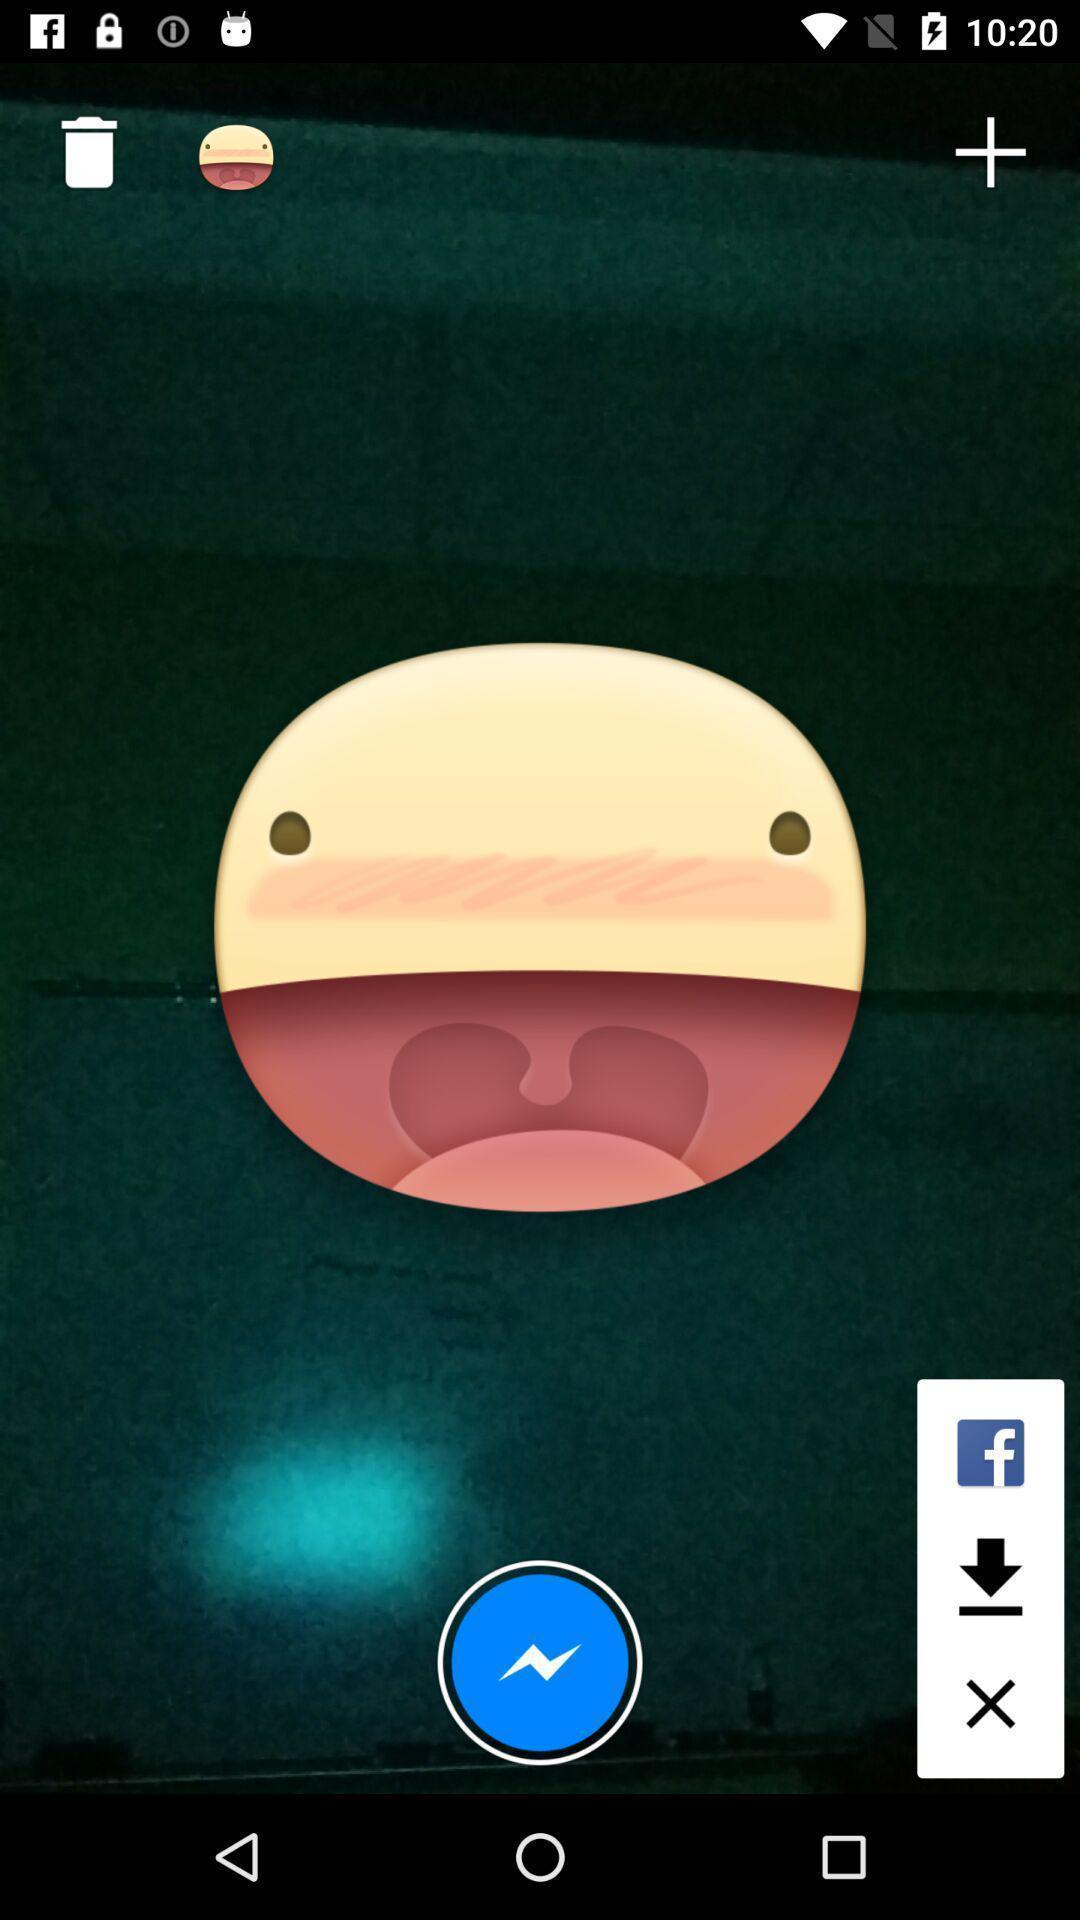Describe this image in words. Page with image of an emotion in a social app. 